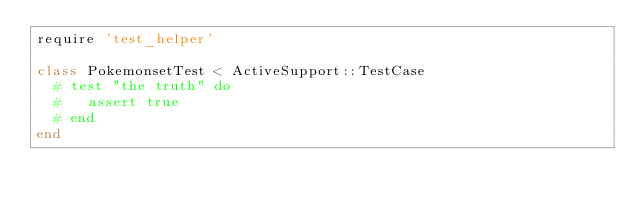Convert code to text. <code><loc_0><loc_0><loc_500><loc_500><_Ruby_>require 'test_helper'

class PokemonsetTest < ActiveSupport::TestCase
  # test "the truth" do
  #   assert true
  # end
end
</code> 